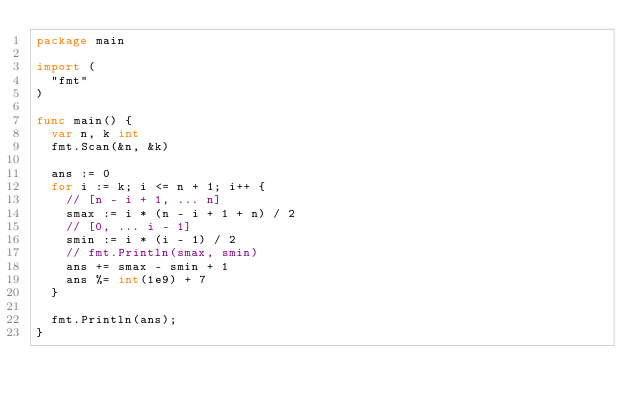Convert code to text. <code><loc_0><loc_0><loc_500><loc_500><_Go_>package main

import (
	"fmt"
)

func main() {
	var n, k int
	fmt.Scan(&n, &k)

	ans := 0
	for i := k; i <= n + 1; i++ {
		// [n - i + 1, ... n]
		smax := i * (n - i + 1 + n) / 2
		// [0, ... i - 1]
		smin := i * (i - 1) / 2
		// fmt.Println(smax, smin)
		ans += smax - smin + 1
		ans %= int(1e9) + 7
	}

	fmt.Println(ans);
}
</code> 